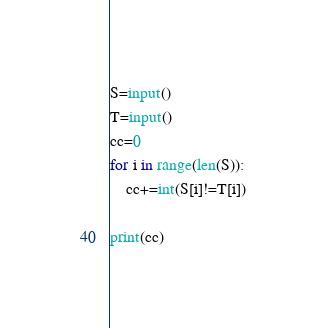<code> <loc_0><loc_0><loc_500><loc_500><_Python_>S=input()
T=input()
cc=0
for i in range(len(S)):
    cc+=int(S[i]!=T[i])

print(cc)</code> 